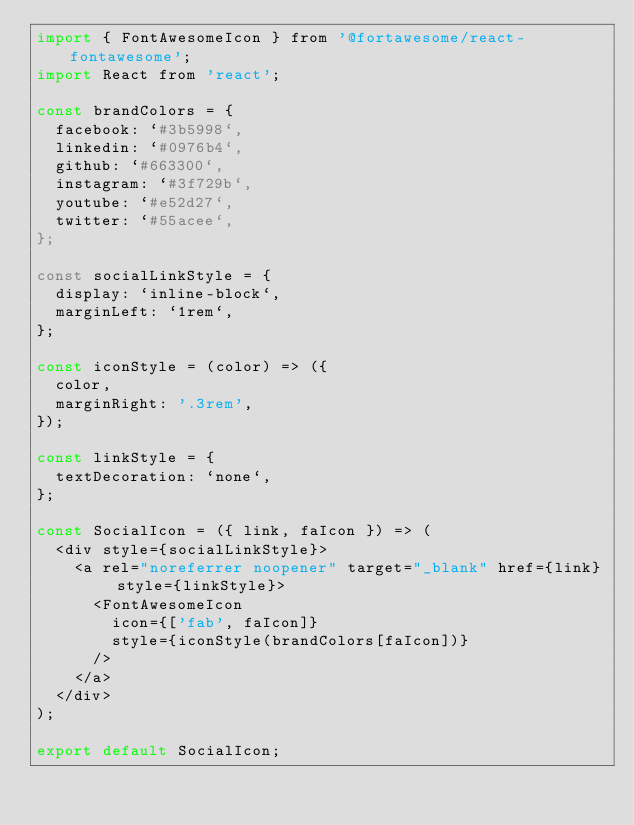<code> <loc_0><loc_0><loc_500><loc_500><_JavaScript_>import { FontAwesomeIcon } from '@fortawesome/react-fontawesome';
import React from 'react';

const brandColors = {
  facebook: `#3b5998`,
  linkedin: `#0976b4`,
  github: `#663300`,
  instagram: `#3f729b`,
  youtube: `#e52d27`,
  twitter: `#55acee`,
};

const socialLinkStyle = {
  display: `inline-block`,
  marginLeft: `1rem`,
};

const iconStyle = (color) => ({
  color,
  marginRight: '.3rem',
});

const linkStyle = {
  textDecoration: `none`,
};

const SocialIcon = ({ link, faIcon }) => (
  <div style={socialLinkStyle}>
    <a rel="noreferrer noopener" target="_blank" href={link} style={linkStyle}>
      <FontAwesomeIcon
        icon={['fab', faIcon]}
        style={iconStyle(brandColors[faIcon])}
      />
    </a>
  </div>
);

export default SocialIcon;
</code> 